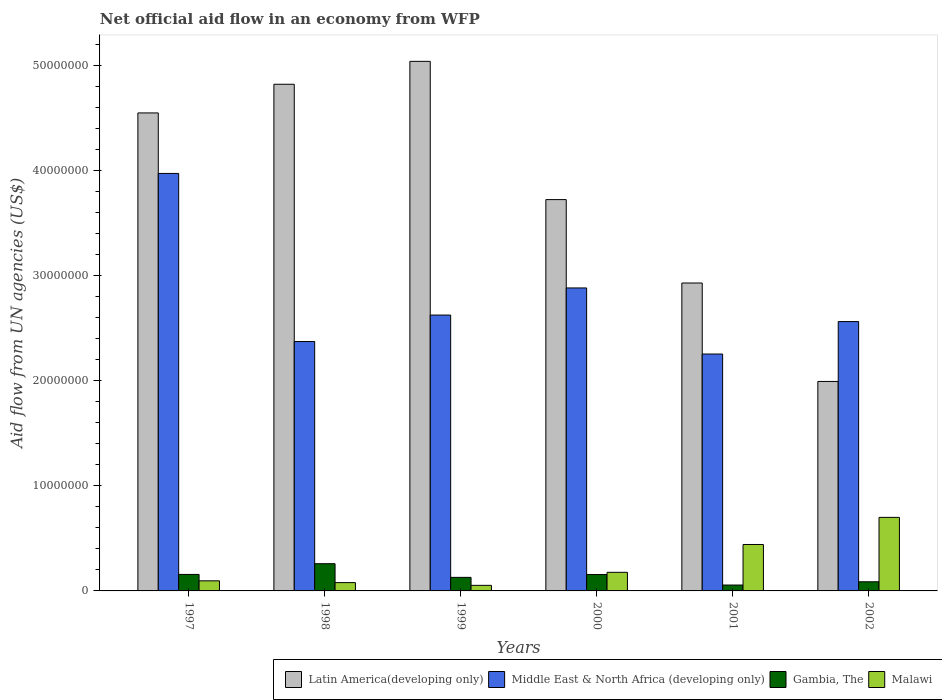How many different coloured bars are there?
Your response must be concise. 4. How many groups of bars are there?
Your response must be concise. 6. Are the number of bars per tick equal to the number of legend labels?
Your response must be concise. Yes. Are the number of bars on each tick of the X-axis equal?
Your response must be concise. Yes. How many bars are there on the 4th tick from the left?
Provide a succinct answer. 4. How many bars are there on the 3rd tick from the right?
Make the answer very short. 4. What is the label of the 1st group of bars from the left?
Provide a short and direct response. 1997. In how many cases, is the number of bars for a given year not equal to the number of legend labels?
Your answer should be very brief. 0. What is the net official aid flow in Latin America(developing only) in 1998?
Keep it short and to the point. 4.82e+07. Across all years, what is the maximum net official aid flow in Latin America(developing only)?
Provide a short and direct response. 5.04e+07. Across all years, what is the minimum net official aid flow in Middle East & North Africa (developing only)?
Offer a terse response. 2.26e+07. In which year was the net official aid flow in Middle East & North Africa (developing only) minimum?
Make the answer very short. 2001. What is the total net official aid flow in Middle East & North Africa (developing only) in the graph?
Keep it short and to the point. 1.67e+08. What is the difference between the net official aid flow in Middle East & North Africa (developing only) in 1998 and that in 2002?
Offer a very short reply. -1.90e+06. What is the difference between the net official aid flow in Latin America(developing only) in 1997 and the net official aid flow in Middle East & North Africa (developing only) in 2001?
Keep it short and to the point. 2.30e+07. What is the average net official aid flow in Latin America(developing only) per year?
Provide a short and direct response. 3.84e+07. In the year 1998, what is the difference between the net official aid flow in Middle East & North Africa (developing only) and net official aid flow in Malawi?
Provide a short and direct response. 2.30e+07. What is the ratio of the net official aid flow in Latin America(developing only) in 1999 to that in 2002?
Your response must be concise. 2.53. Is the net official aid flow in Middle East & North Africa (developing only) in 1997 less than that in 1999?
Your response must be concise. No. Is the difference between the net official aid flow in Middle East & North Africa (developing only) in 1999 and 2000 greater than the difference between the net official aid flow in Malawi in 1999 and 2000?
Make the answer very short. No. What is the difference between the highest and the second highest net official aid flow in Latin America(developing only)?
Keep it short and to the point. 2.18e+06. What is the difference between the highest and the lowest net official aid flow in Latin America(developing only)?
Your answer should be very brief. 3.05e+07. Is it the case that in every year, the sum of the net official aid flow in Gambia, The and net official aid flow in Malawi is greater than the sum of net official aid flow in Middle East & North Africa (developing only) and net official aid flow in Latin America(developing only)?
Keep it short and to the point. No. What does the 1st bar from the left in 2000 represents?
Provide a succinct answer. Latin America(developing only). What does the 4th bar from the right in 1998 represents?
Provide a short and direct response. Latin America(developing only). Is it the case that in every year, the sum of the net official aid flow in Malawi and net official aid flow in Latin America(developing only) is greater than the net official aid flow in Gambia, The?
Offer a terse response. Yes. Are all the bars in the graph horizontal?
Provide a short and direct response. No. How many years are there in the graph?
Your answer should be very brief. 6. What is the difference between two consecutive major ticks on the Y-axis?
Your response must be concise. 1.00e+07. Are the values on the major ticks of Y-axis written in scientific E-notation?
Your response must be concise. No. Does the graph contain any zero values?
Provide a succinct answer. No. Does the graph contain grids?
Ensure brevity in your answer.  No. How many legend labels are there?
Your response must be concise. 4. What is the title of the graph?
Your answer should be compact. Net official aid flow in an economy from WFP. What is the label or title of the Y-axis?
Your answer should be compact. Aid flow from UN agencies (US$). What is the Aid flow from UN agencies (US$) of Latin America(developing only) in 1997?
Offer a terse response. 4.55e+07. What is the Aid flow from UN agencies (US$) in Middle East & North Africa (developing only) in 1997?
Your answer should be very brief. 3.97e+07. What is the Aid flow from UN agencies (US$) of Gambia, The in 1997?
Keep it short and to the point. 1.57e+06. What is the Aid flow from UN agencies (US$) in Malawi in 1997?
Ensure brevity in your answer.  9.60e+05. What is the Aid flow from UN agencies (US$) of Latin America(developing only) in 1998?
Ensure brevity in your answer.  4.82e+07. What is the Aid flow from UN agencies (US$) of Middle East & North Africa (developing only) in 1998?
Give a very brief answer. 2.37e+07. What is the Aid flow from UN agencies (US$) in Gambia, The in 1998?
Your response must be concise. 2.59e+06. What is the Aid flow from UN agencies (US$) of Malawi in 1998?
Your answer should be compact. 7.90e+05. What is the Aid flow from UN agencies (US$) in Latin America(developing only) in 1999?
Offer a terse response. 5.04e+07. What is the Aid flow from UN agencies (US$) of Middle East & North Africa (developing only) in 1999?
Your answer should be very brief. 2.63e+07. What is the Aid flow from UN agencies (US$) of Gambia, The in 1999?
Your answer should be compact. 1.29e+06. What is the Aid flow from UN agencies (US$) in Malawi in 1999?
Provide a short and direct response. 5.30e+05. What is the Aid flow from UN agencies (US$) of Latin America(developing only) in 2000?
Keep it short and to the point. 3.72e+07. What is the Aid flow from UN agencies (US$) in Middle East & North Africa (developing only) in 2000?
Give a very brief answer. 2.88e+07. What is the Aid flow from UN agencies (US$) in Gambia, The in 2000?
Offer a terse response. 1.56e+06. What is the Aid flow from UN agencies (US$) of Malawi in 2000?
Make the answer very short. 1.77e+06. What is the Aid flow from UN agencies (US$) in Latin America(developing only) in 2001?
Offer a very short reply. 2.93e+07. What is the Aid flow from UN agencies (US$) of Middle East & North Africa (developing only) in 2001?
Keep it short and to the point. 2.26e+07. What is the Aid flow from UN agencies (US$) of Gambia, The in 2001?
Your response must be concise. 5.60e+05. What is the Aid flow from UN agencies (US$) in Malawi in 2001?
Provide a short and direct response. 4.42e+06. What is the Aid flow from UN agencies (US$) in Latin America(developing only) in 2002?
Offer a very short reply. 1.99e+07. What is the Aid flow from UN agencies (US$) of Middle East & North Africa (developing only) in 2002?
Ensure brevity in your answer.  2.56e+07. What is the Aid flow from UN agencies (US$) of Gambia, The in 2002?
Provide a succinct answer. 8.70e+05. Across all years, what is the maximum Aid flow from UN agencies (US$) of Latin America(developing only)?
Make the answer very short. 5.04e+07. Across all years, what is the maximum Aid flow from UN agencies (US$) in Middle East & North Africa (developing only)?
Make the answer very short. 3.97e+07. Across all years, what is the maximum Aid flow from UN agencies (US$) of Gambia, The?
Make the answer very short. 2.59e+06. Across all years, what is the minimum Aid flow from UN agencies (US$) in Latin America(developing only)?
Give a very brief answer. 1.99e+07. Across all years, what is the minimum Aid flow from UN agencies (US$) of Middle East & North Africa (developing only)?
Your answer should be compact. 2.26e+07. Across all years, what is the minimum Aid flow from UN agencies (US$) in Gambia, The?
Offer a very short reply. 5.60e+05. Across all years, what is the minimum Aid flow from UN agencies (US$) of Malawi?
Give a very brief answer. 5.30e+05. What is the total Aid flow from UN agencies (US$) of Latin America(developing only) in the graph?
Provide a succinct answer. 2.31e+08. What is the total Aid flow from UN agencies (US$) of Middle East & North Africa (developing only) in the graph?
Offer a very short reply. 1.67e+08. What is the total Aid flow from UN agencies (US$) in Gambia, The in the graph?
Provide a succinct answer. 8.44e+06. What is the total Aid flow from UN agencies (US$) of Malawi in the graph?
Provide a succinct answer. 1.55e+07. What is the difference between the Aid flow from UN agencies (US$) of Latin America(developing only) in 1997 and that in 1998?
Ensure brevity in your answer.  -2.73e+06. What is the difference between the Aid flow from UN agencies (US$) in Middle East & North Africa (developing only) in 1997 and that in 1998?
Offer a very short reply. 1.60e+07. What is the difference between the Aid flow from UN agencies (US$) in Gambia, The in 1997 and that in 1998?
Provide a short and direct response. -1.02e+06. What is the difference between the Aid flow from UN agencies (US$) in Latin America(developing only) in 1997 and that in 1999?
Offer a terse response. -4.91e+06. What is the difference between the Aid flow from UN agencies (US$) in Middle East & North Africa (developing only) in 1997 and that in 1999?
Your answer should be compact. 1.35e+07. What is the difference between the Aid flow from UN agencies (US$) of Gambia, The in 1997 and that in 1999?
Provide a succinct answer. 2.80e+05. What is the difference between the Aid flow from UN agencies (US$) of Malawi in 1997 and that in 1999?
Provide a short and direct response. 4.30e+05. What is the difference between the Aid flow from UN agencies (US$) in Latin America(developing only) in 1997 and that in 2000?
Provide a short and direct response. 8.25e+06. What is the difference between the Aid flow from UN agencies (US$) in Middle East & North Africa (developing only) in 1997 and that in 2000?
Make the answer very short. 1.09e+07. What is the difference between the Aid flow from UN agencies (US$) in Gambia, The in 1997 and that in 2000?
Provide a short and direct response. 10000. What is the difference between the Aid flow from UN agencies (US$) in Malawi in 1997 and that in 2000?
Ensure brevity in your answer.  -8.10e+05. What is the difference between the Aid flow from UN agencies (US$) of Latin America(developing only) in 1997 and that in 2001?
Make the answer very short. 1.62e+07. What is the difference between the Aid flow from UN agencies (US$) of Middle East & North Africa (developing only) in 1997 and that in 2001?
Your response must be concise. 1.72e+07. What is the difference between the Aid flow from UN agencies (US$) of Gambia, The in 1997 and that in 2001?
Make the answer very short. 1.01e+06. What is the difference between the Aid flow from UN agencies (US$) in Malawi in 1997 and that in 2001?
Your answer should be compact. -3.46e+06. What is the difference between the Aid flow from UN agencies (US$) in Latin America(developing only) in 1997 and that in 2002?
Ensure brevity in your answer.  2.56e+07. What is the difference between the Aid flow from UN agencies (US$) in Middle East & North Africa (developing only) in 1997 and that in 2002?
Give a very brief answer. 1.41e+07. What is the difference between the Aid flow from UN agencies (US$) in Gambia, The in 1997 and that in 2002?
Offer a very short reply. 7.00e+05. What is the difference between the Aid flow from UN agencies (US$) in Malawi in 1997 and that in 2002?
Provide a short and direct response. -6.04e+06. What is the difference between the Aid flow from UN agencies (US$) in Latin America(developing only) in 1998 and that in 1999?
Provide a short and direct response. -2.18e+06. What is the difference between the Aid flow from UN agencies (US$) in Middle East & North Africa (developing only) in 1998 and that in 1999?
Offer a terse response. -2.52e+06. What is the difference between the Aid flow from UN agencies (US$) of Gambia, The in 1998 and that in 1999?
Give a very brief answer. 1.30e+06. What is the difference between the Aid flow from UN agencies (US$) of Malawi in 1998 and that in 1999?
Offer a terse response. 2.60e+05. What is the difference between the Aid flow from UN agencies (US$) of Latin America(developing only) in 1998 and that in 2000?
Your answer should be compact. 1.10e+07. What is the difference between the Aid flow from UN agencies (US$) of Middle East & North Africa (developing only) in 1998 and that in 2000?
Your response must be concise. -5.10e+06. What is the difference between the Aid flow from UN agencies (US$) in Gambia, The in 1998 and that in 2000?
Ensure brevity in your answer.  1.03e+06. What is the difference between the Aid flow from UN agencies (US$) of Malawi in 1998 and that in 2000?
Make the answer very short. -9.80e+05. What is the difference between the Aid flow from UN agencies (US$) of Latin America(developing only) in 1998 and that in 2001?
Offer a terse response. 1.89e+07. What is the difference between the Aid flow from UN agencies (US$) in Middle East & North Africa (developing only) in 1998 and that in 2001?
Offer a very short reply. 1.19e+06. What is the difference between the Aid flow from UN agencies (US$) in Gambia, The in 1998 and that in 2001?
Offer a very short reply. 2.03e+06. What is the difference between the Aid flow from UN agencies (US$) of Malawi in 1998 and that in 2001?
Your response must be concise. -3.63e+06. What is the difference between the Aid flow from UN agencies (US$) of Latin America(developing only) in 1998 and that in 2002?
Ensure brevity in your answer.  2.83e+07. What is the difference between the Aid flow from UN agencies (US$) in Middle East & North Africa (developing only) in 1998 and that in 2002?
Provide a short and direct response. -1.90e+06. What is the difference between the Aid flow from UN agencies (US$) in Gambia, The in 1998 and that in 2002?
Your answer should be compact. 1.72e+06. What is the difference between the Aid flow from UN agencies (US$) of Malawi in 1998 and that in 2002?
Your response must be concise. -6.21e+06. What is the difference between the Aid flow from UN agencies (US$) of Latin America(developing only) in 1999 and that in 2000?
Offer a very short reply. 1.32e+07. What is the difference between the Aid flow from UN agencies (US$) of Middle East & North Africa (developing only) in 1999 and that in 2000?
Your answer should be compact. -2.58e+06. What is the difference between the Aid flow from UN agencies (US$) of Gambia, The in 1999 and that in 2000?
Keep it short and to the point. -2.70e+05. What is the difference between the Aid flow from UN agencies (US$) in Malawi in 1999 and that in 2000?
Offer a terse response. -1.24e+06. What is the difference between the Aid flow from UN agencies (US$) in Latin America(developing only) in 1999 and that in 2001?
Make the answer very short. 2.11e+07. What is the difference between the Aid flow from UN agencies (US$) of Middle East & North Africa (developing only) in 1999 and that in 2001?
Give a very brief answer. 3.71e+06. What is the difference between the Aid flow from UN agencies (US$) in Gambia, The in 1999 and that in 2001?
Give a very brief answer. 7.30e+05. What is the difference between the Aid flow from UN agencies (US$) of Malawi in 1999 and that in 2001?
Provide a succinct answer. -3.89e+06. What is the difference between the Aid flow from UN agencies (US$) of Latin America(developing only) in 1999 and that in 2002?
Keep it short and to the point. 3.05e+07. What is the difference between the Aid flow from UN agencies (US$) in Middle East & North Africa (developing only) in 1999 and that in 2002?
Give a very brief answer. 6.20e+05. What is the difference between the Aid flow from UN agencies (US$) of Gambia, The in 1999 and that in 2002?
Give a very brief answer. 4.20e+05. What is the difference between the Aid flow from UN agencies (US$) in Malawi in 1999 and that in 2002?
Your answer should be very brief. -6.47e+06. What is the difference between the Aid flow from UN agencies (US$) in Latin America(developing only) in 2000 and that in 2001?
Your answer should be compact. 7.94e+06. What is the difference between the Aid flow from UN agencies (US$) in Middle East & North Africa (developing only) in 2000 and that in 2001?
Offer a very short reply. 6.29e+06. What is the difference between the Aid flow from UN agencies (US$) of Gambia, The in 2000 and that in 2001?
Offer a very short reply. 1.00e+06. What is the difference between the Aid flow from UN agencies (US$) of Malawi in 2000 and that in 2001?
Offer a terse response. -2.65e+06. What is the difference between the Aid flow from UN agencies (US$) in Latin America(developing only) in 2000 and that in 2002?
Make the answer very short. 1.73e+07. What is the difference between the Aid flow from UN agencies (US$) in Middle East & North Africa (developing only) in 2000 and that in 2002?
Keep it short and to the point. 3.20e+06. What is the difference between the Aid flow from UN agencies (US$) of Gambia, The in 2000 and that in 2002?
Your answer should be very brief. 6.90e+05. What is the difference between the Aid flow from UN agencies (US$) of Malawi in 2000 and that in 2002?
Your response must be concise. -5.23e+06. What is the difference between the Aid flow from UN agencies (US$) in Latin America(developing only) in 2001 and that in 2002?
Offer a terse response. 9.37e+06. What is the difference between the Aid flow from UN agencies (US$) of Middle East & North Africa (developing only) in 2001 and that in 2002?
Make the answer very short. -3.09e+06. What is the difference between the Aid flow from UN agencies (US$) of Gambia, The in 2001 and that in 2002?
Make the answer very short. -3.10e+05. What is the difference between the Aid flow from UN agencies (US$) in Malawi in 2001 and that in 2002?
Make the answer very short. -2.58e+06. What is the difference between the Aid flow from UN agencies (US$) of Latin America(developing only) in 1997 and the Aid flow from UN agencies (US$) of Middle East & North Africa (developing only) in 1998?
Offer a terse response. 2.18e+07. What is the difference between the Aid flow from UN agencies (US$) of Latin America(developing only) in 1997 and the Aid flow from UN agencies (US$) of Gambia, The in 1998?
Your answer should be very brief. 4.29e+07. What is the difference between the Aid flow from UN agencies (US$) in Latin America(developing only) in 1997 and the Aid flow from UN agencies (US$) in Malawi in 1998?
Offer a terse response. 4.47e+07. What is the difference between the Aid flow from UN agencies (US$) of Middle East & North Africa (developing only) in 1997 and the Aid flow from UN agencies (US$) of Gambia, The in 1998?
Provide a short and direct response. 3.72e+07. What is the difference between the Aid flow from UN agencies (US$) in Middle East & North Africa (developing only) in 1997 and the Aid flow from UN agencies (US$) in Malawi in 1998?
Give a very brief answer. 3.90e+07. What is the difference between the Aid flow from UN agencies (US$) of Gambia, The in 1997 and the Aid flow from UN agencies (US$) of Malawi in 1998?
Ensure brevity in your answer.  7.80e+05. What is the difference between the Aid flow from UN agencies (US$) of Latin America(developing only) in 1997 and the Aid flow from UN agencies (US$) of Middle East & North Africa (developing only) in 1999?
Your response must be concise. 1.92e+07. What is the difference between the Aid flow from UN agencies (US$) of Latin America(developing only) in 1997 and the Aid flow from UN agencies (US$) of Gambia, The in 1999?
Provide a short and direct response. 4.42e+07. What is the difference between the Aid flow from UN agencies (US$) in Latin America(developing only) in 1997 and the Aid flow from UN agencies (US$) in Malawi in 1999?
Offer a very short reply. 4.50e+07. What is the difference between the Aid flow from UN agencies (US$) in Middle East & North Africa (developing only) in 1997 and the Aid flow from UN agencies (US$) in Gambia, The in 1999?
Make the answer very short. 3.84e+07. What is the difference between the Aid flow from UN agencies (US$) in Middle East & North Africa (developing only) in 1997 and the Aid flow from UN agencies (US$) in Malawi in 1999?
Your answer should be compact. 3.92e+07. What is the difference between the Aid flow from UN agencies (US$) in Gambia, The in 1997 and the Aid flow from UN agencies (US$) in Malawi in 1999?
Give a very brief answer. 1.04e+06. What is the difference between the Aid flow from UN agencies (US$) in Latin America(developing only) in 1997 and the Aid flow from UN agencies (US$) in Middle East & North Africa (developing only) in 2000?
Make the answer very short. 1.67e+07. What is the difference between the Aid flow from UN agencies (US$) of Latin America(developing only) in 1997 and the Aid flow from UN agencies (US$) of Gambia, The in 2000?
Make the answer very short. 4.39e+07. What is the difference between the Aid flow from UN agencies (US$) in Latin America(developing only) in 1997 and the Aid flow from UN agencies (US$) in Malawi in 2000?
Your response must be concise. 4.37e+07. What is the difference between the Aid flow from UN agencies (US$) in Middle East & North Africa (developing only) in 1997 and the Aid flow from UN agencies (US$) in Gambia, The in 2000?
Make the answer very short. 3.82e+07. What is the difference between the Aid flow from UN agencies (US$) of Middle East & North Africa (developing only) in 1997 and the Aid flow from UN agencies (US$) of Malawi in 2000?
Provide a succinct answer. 3.80e+07. What is the difference between the Aid flow from UN agencies (US$) of Gambia, The in 1997 and the Aid flow from UN agencies (US$) of Malawi in 2000?
Your response must be concise. -2.00e+05. What is the difference between the Aid flow from UN agencies (US$) in Latin America(developing only) in 1997 and the Aid flow from UN agencies (US$) in Middle East & North Africa (developing only) in 2001?
Ensure brevity in your answer.  2.30e+07. What is the difference between the Aid flow from UN agencies (US$) in Latin America(developing only) in 1997 and the Aid flow from UN agencies (US$) in Gambia, The in 2001?
Offer a terse response. 4.49e+07. What is the difference between the Aid flow from UN agencies (US$) of Latin America(developing only) in 1997 and the Aid flow from UN agencies (US$) of Malawi in 2001?
Provide a succinct answer. 4.11e+07. What is the difference between the Aid flow from UN agencies (US$) in Middle East & North Africa (developing only) in 1997 and the Aid flow from UN agencies (US$) in Gambia, The in 2001?
Your answer should be very brief. 3.92e+07. What is the difference between the Aid flow from UN agencies (US$) of Middle East & North Africa (developing only) in 1997 and the Aid flow from UN agencies (US$) of Malawi in 2001?
Ensure brevity in your answer.  3.53e+07. What is the difference between the Aid flow from UN agencies (US$) in Gambia, The in 1997 and the Aid flow from UN agencies (US$) in Malawi in 2001?
Give a very brief answer. -2.85e+06. What is the difference between the Aid flow from UN agencies (US$) of Latin America(developing only) in 1997 and the Aid flow from UN agencies (US$) of Middle East & North Africa (developing only) in 2002?
Offer a terse response. 1.99e+07. What is the difference between the Aid flow from UN agencies (US$) of Latin America(developing only) in 1997 and the Aid flow from UN agencies (US$) of Gambia, The in 2002?
Ensure brevity in your answer.  4.46e+07. What is the difference between the Aid flow from UN agencies (US$) in Latin America(developing only) in 1997 and the Aid flow from UN agencies (US$) in Malawi in 2002?
Offer a terse response. 3.85e+07. What is the difference between the Aid flow from UN agencies (US$) in Middle East & North Africa (developing only) in 1997 and the Aid flow from UN agencies (US$) in Gambia, The in 2002?
Offer a very short reply. 3.89e+07. What is the difference between the Aid flow from UN agencies (US$) in Middle East & North Africa (developing only) in 1997 and the Aid flow from UN agencies (US$) in Malawi in 2002?
Your answer should be compact. 3.27e+07. What is the difference between the Aid flow from UN agencies (US$) in Gambia, The in 1997 and the Aid flow from UN agencies (US$) in Malawi in 2002?
Ensure brevity in your answer.  -5.43e+06. What is the difference between the Aid flow from UN agencies (US$) of Latin America(developing only) in 1998 and the Aid flow from UN agencies (US$) of Middle East & North Africa (developing only) in 1999?
Provide a short and direct response. 2.20e+07. What is the difference between the Aid flow from UN agencies (US$) in Latin America(developing only) in 1998 and the Aid flow from UN agencies (US$) in Gambia, The in 1999?
Keep it short and to the point. 4.69e+07. What is the difference between the Aid flow from UN agencies (US$) in Latin America(developing only) in 1998 and the Aid flow from UN agencies (US$) in Malawi in 1999?
Provide a short and direct response. 4.77e+07. What is the difference between the Aid flow from UN agencies (US$) of Middle East & North Africa (developing only) in 1998 and the Aid flow from UN agencies (US$) of Gambia, The in 1999?
Your response must be concise. 2.24e+07. What is the difference between the Aid flow from UN agencies (US$) in Middle East & North Africa (developing only) in 1998 and the Aid flow from UN agencies (US$) in Malawi in 1999?
Keep it short and to the point. 2.32e+07. What is the difference between the Aid flow from UN agencies (US$) of Gambia, The in 1998 and the Aid flow from UN agencies (US$) of Malawi in 1999?
Offer a terse response. 2.06e+06. What is the difference between the Aid flow from UN agencies (US$) in Latin America(developing only) in 1998 and the Aid flow from UN agencies (US$) in Middle East & North Africa (developing only) in 2000?
Provide a succinct answer. 1.94e+07. What is the difference between the Aid flow from UN agencies (US$) in Latin America(developing only) in 1998 and the Aid flow from UN agencies (US$) in Gambia, The in 2000?
Provide a short and direct response. 4.67e+07. What is the difference between the Aid flow from UN agencies (US$) of Latin America(developing only) in 1998 and the Aid flow from UN agencies (US$) of Malawi in 2000?
Your answer should be very brief. 4.65e+07. What is the difference between the Aid flow from UN agencies (US$) in Middle East & North Africa (developing only) in 1998 and the Aid flow from UN agencies (US$) in Gambia, The in 2000?
Provide a succinct answer. 2.22e+07. What is the difference between the Aid flow from UN agencies (US$) in Middle East & North Africa (developing only) in 1998 and the Aid flow from UN agencies (US$) in Malawi in 2000?
Make the answer very short. 2.20e+07. What is the difference between the Aid flow from UN agencies (US$) in Gambia, The in 1998 and the Aid flow from UN agencies (US$) in Malawi in 2000?
Provide a succinct answer. 8.20e+05. What is the difference between the Aid flow from UN agencies (US$) of Latin America(developing only) in 1998 and the Aid flow from UN agencies (US$) of Middle East & North Africa (developing only) in 2001?
Ensure brevity in your answer.  2.57e+07. What is the difference between the Aid flow from UN agencies (US$) of Latin America(developing only) in 1998 and the Aid flow from UN agencies (US$) of Gambia, The in 2001?
Make the answer very short. 4.77e+07. What is the difference between the Aid flow from UN agencies (US$) of Latin America(developing only) in 1998 and the Aid flow from UN agencies (US$) of Malawi in 2001?
Your answer should be compact. 4.38e+07. What is the difference between the Aid flow from UN agencies (US$) in Middle East & North Africa (developing only) in 1998 and the Aid flow from UN agencies (US$) in Gambia, The in 2001?
Your response must be concise. 2.32e+07. What is the difference between the Aid flow from UN agencies (US$) of Middle East & North Africa (developing only) in 1998 and the Aid flow from UN agencies (US$) of Malawi in 2001?
Make the answer very short. 1.93e+07. What is the difference between the Aid flow from UN agencies (US$) in Gambia, The in 1998 and the Aid flow from UN agencies (US$) in Malawi in 2001?
Keep it short and to the point. -1.83e+06. What is the difference between the Aid flow from UN agencies (US$) in Latin America(developing only) in 1998 and the Aid flow from UN agencies (US$) in Middle East & North Africa (developing only) in 2002?
Your answer should be very brief. 2.26e+07. What is the difference between the Aid flow from UN agencies (US$) in Latin America(developing only) in 1998 and the Aid flow from UN agencies (US$) in Gambia, The in 2002?
Provide a succinct answer. 4.74e+07. What is the difference between the Aid flow from UN agencies (US$) of Latin America(developing only) in 1998 and the Aid flow from UN agencies (US$) of Malawi in 2002?
Your response must be concise. 4.12e+07. What is the difference between the Aid flow from UN agencies (US$) of Middle East & North Africa (developing only) in 1998 and the Aid flow from UN agencies (US$) of Gambia, The in 2002?
Your answer should be very brief. 2.29e+07. What is the difference between the Aid flow from UN agencies (US$) of Middle East & North Africa (developing only) in 1998 and the Aid flow from UN agencies (US$) of Malawi in 2002?
Your answer should be compact. 1.67e+07. What is the difference between the Aid flow from UN agencies (US$) in Gambia, The in 1998 and the Aid flow from UN agencies (US$) in Malawi in 2002?
Your answer should be compact. -4.41e+06. What is the difference between the Aid flow from UN agencies (US$) of Latin America(developing only) in 1999 and the Aid flow from UN agencies (US$) of Middle East & North Africa (developing only) in 2000?
Your answer should be compact. 2.16e+07. What is the difference between the Aid flow from UN agencies (US$) in Latin America(developing only) in 1999 and the Aid flow from UN agencies (US$) in Gambia, The in 2000?
Make the answer very short. 4.88e+07. What is the difference between the Aid flow from UN agencies (US$) in Latin America(developing only) in 1999 and the Aid flow from UN agencies (US$) in Malawi in 2000?
Your answer should be very brief. 4.86e+07. What is the difference between the Aid flow from UN agencies (US$) in Middle East & North Africa (developing only) in 1999 and the Aid flow from UN agencies (US$) in Gambia, The in 2000?
Your response must be concise. 2.47e+07. What is the difference between the Aid flow from UN agencies (US$) in Middle East & North Africa (developing only) in 1999 and the Aid flow from UN agencies (US$) in Malawi in 2000?
Offer a very short reply. 2.45e+07. What is the difference between the Aid flow from UN agencies (US$) of Gambia, The in 1999 and the Aid flow from UN agencies (US$) of Malawi in 2000?
Provide a succinct answer. -4.80e+05. What is the difference between the Aid flow from UN agencies (US$) in Latin America(developing only) in 1999 and the Aid flow from UN agencies (US$) in Middle East & North Africa (developing only) in 2001?
Your answer should be very brief. 2.79e+07. What is the difference between the Aid flow from UN agencies (US$) of Latin America(developing only) in 1999 and the Aid flow from UN agencies (US$) of Gambia, The in 2001?
Provide a succinct answer. 4.98e+07. What is the difference between the Aid flow from UN agencies (US$) in Latin America(developing only) in 1999 and the Aid flow from UN agencies (US$) in Malawi in 2001?
Your answer should be compact. 4.60e+07. What is the difference between the Aid flow from UN agencies (US$) in Middle East & North Africa (developing only) in 1999 and the Aid flow from UN agencies (US$) in Gambia, The in 2001?
Ensure brevity in your answer.  2.57e+07. What is the difference between the Aid flow from UN agencies (US$) of Middle East & North Africa (developing only) in 1999 and the Aid flow from UN agencies (US$) of Malawi in 2001?
Provide a short and direct response. 2.18e+07. What is the difference between the Aid flow from UN agencies (US$) of Gambia, The in 1999 and the Aid flow from UN agencies (US$) of Malawi in 2001?
Provide a succinct answer. -3.13e+06. What is the difference between the Aid flow from UN agencies (US$) of Latin America(developing only) in 1999 and the Aid flow from UN agencies (US$) of Middle East & North Africa (developing only) in 2002?
Your response must be concise. 2.48e+07. What is the difference between the Aid flow from UN agencies (US$) of Latin America(developing only) in 1999 and the Aid flow from UN agencies (US$) of Gambia, The in 2002?
Your answer should be compact. 4.95e+07. What is the difference between the Aid flow from UN agencies (US$) in Latin America(developing only) in 1999 and the Aid flow from UN agencies (US$) in Malawi in 2002?
Make the answer very short. 4.34e+07. What is the difference between the Aid flow from UN agencies (US$) in Middle East & North Africa (developing only) in 1999 and the Aid flow from UN agencies (US$) in Gambia, The in 2002?
Ensure brevity in your answer.  2.54e+07. What is the difference between the Aid flow from UN agencies (US$) of Middle East & North Africa (developing only) in 1999 and the Aid flow from UN agencies (US$) of Malawi in 2002?
Offer a very short reply. 1.93e+07. What is the difference between the Aid flow from UN agencies (US$) in Gambia, The in 1999 and the Aid flow from UN agencies (US$) in Malawi in 2002?
Provide a succinct answer. -5.71e+06. What is the difference between the Aid flow from UN agencies (US$) of Latin America(developing only) in 2000 and the Aid flow from UN agencies (US$) of Middle East & North Africa (developing only) in 2001?
Your answer should be very brief. 1.47e+07. What is the difference between the Aid flow from UN agencies (US$) of Latin America(developing only) in 2000 and the Aid flow from UN agencies (US$) of Gambia, The in 2001?
Give a very brief answer. 3.67e+07. What is the difference between the Aid flow from UN agencies (US$) of Latin America(developing only) in 2000 and the Aid flow from UN agencies (US$) of Malawi in 2001?
Ensure brevity in your answer.  3.28e+07. What is the difference between the Aid flow from UN agencies (US$) of Middle East & North Africa (developing only) in 2000 and the Aid flow from UN agencies (US$) of Gambia, The in 2001?
Keep it short and to the point. 2.83e+07. What is the difference between the Aid flow from UN agencies (US$) in Middle East & North Africa (developing only) in 2000 and the Aid flow from UN agencies (US$) in Malawi in 2001?
Ensure brevity in your answer.  2.44e+07. What is the difference between the Aid flow from UN agencies (US$) in Gambia, The in 2000 and the Aid flow from UN agencies (US$) in Malawi in 2001?
Your response must be concise. -2.86e+06. What is the difference between the Aid flow from UN agencies (US$) in Latin America(developing only) in 2000 and the Aid flow from UN agencies (US$) in Middle East & North Africa (developing only) in 2002?
Ensure brevity in your answer.  1.16e+07. What is the difference between the Aid flow from UN agencies (US$) of Latin America(developing only) in 2000 and the Aid flow from UN agencies (US$) of Gambia, The in 2002?
Keep it short and to the point. 3.64e+07. What is the difference between the Aid flow from UN agencies (US$) in Latin America(developing only) in 2000 and the Aid flow from UN agencies (US$) in Malawi in 2002?
Ensure brevity in your answer.  3.02e+07. What is the difference between the Aid flow from UN agencies (US$) in Middle East & North Africa (developing only) in 2000 and the Aid flow from UN agencies (US$) in Gambia, The in 2002?
Give a very brief answer. 2.80e+07. What is the difference between the Aid flow from UN agencies (US$) in Middle East & North Africa (developing only) in 2000 and the Aid flow from UN agencies (US$) in Malawi in 2002?
Your answer should be very brief. 2.18e+07. What is the difference between the Aid flow from UN agencies (US$) in Gambia, The in 2000 and the Aid flow from UN agencies (US$) in Malawi in 2002?
Offer a very short reply. -5.44e+06. What is the difference between the Aid flow from UN agencies (US$) of Latin America(developing only) in 2001 and the Aid flow from UN agencies (US$) of Middle East & North Africa (developing only) in 2002?
Make the answer very short. 3.67e+06. What is the difference between the Aid flow from UN agencies (US$) in Latin America(developing only) in 2001 and the Aid flow from UN agencies (US$) in Gambia, The in 2002?
Keep it short and to the point. 2.84e+07. What is the difference between the Aid flow from UN agencies (US$) in Latin America(developing only) in 2001 and the Aid flow from UN agencies (US$) in Malawi in 2002?
Offer a very short reply. 2.23e+07. What is the difference between the Aid flow from UN agencies (US$) in Middle East & North Africa (developing only) in 2001 and the Aid flow from UN agencies (US$) in Gambia, The in 2002?
Offer a terse response. 2.17e+07. What is the difference between the Aid flow from UN agencies (US$) of Middle East & North Africa (developing only) in 2001 and the Aid flow from UN agencies (US$) of Malawi in 2002?
Provide a succinct answer. 1.56e+07. What is the difference between the Aid flow from UN agencies (US$) in Gambia, The in 2001 and the Aid flow from UN agencies (US$) in Malawi in 2002?
Make the answer very short. -6.44e+06. What is the average Aid flow from UN agencies (US$) in Latin America(developing only) per year?
Ensure brevity in your answer.  3.84e+07. What is the average Aid flow from UN agencies (US$) of Middle East & North Africa (developing only) per year?
Your answer should be compact. 2.78e+07. What is the average Aid flow from UN agencies (US$) in Gambia, The per year?
Provide a succinct answer. 1.41e+06. What is the average Aid flow from UN agencies (US$) in Malawi per year?
Offer a terse response. 2.58e+06. In the year 1997, what is the difference between the Aid flow from UN agencies (US$) of Latin America(developing only) and Aid flow from UN agencies (US$) of Middle East & North Africa (developing only)?
Offer a terse response. 5.76e+06. In the year 1997, what is the difference between the Aid flow from UN agencies (US$) in Latin America(developing only) and Aid flow from UN agencies (US$) in Gambia, The?
Provide a short and direct response. 4.39e+07. In the year 1997, what is the difference between the Aid flow from UN agencies (US$) of Latin America(developing only) and Aid flow from UN agencies (US$) of Malawi?
Ensure brevity in your answer.  4.45e+07. In the year 1997, what is the difference between the Aid flow from UN agencies (US$) of Middle East & North Africa (developing only) and Aid flow from UN agencies (US$) of Gambia, The?
Your answer should be compact. 3.82e+07. In the year 1997, what is the difference between the Aid flow from UN agencies (US$) of Middle East & North Africa (developing only) and Aid flow from UN agencies (US$) of Malawi?
Provide a succinct answer. 3.88e+07. In the year 1997, what is the difference between the Aid flow from UN agencies (US$) of Gambia, The and Aid flow from UN agencies (US$) of Malawi?
Offer a very short reply. 6.10e+05. In the year 1998, what is the difference between the Aid flow from UN agencies (US$) of Latin America(developing only) and Aid flow from UN agencies (US$) of Middle East & North Africa (developing only)?
Your answer should be very brief. 2.45e+07. In the year 1998, what is the difference between the Aid flow from UN agencies (US$) of Latin America(developing only) and Aid flow from UN agencies (US$) of Gambia, The?
Your answer should be compact. 4.56e+07. In the year 1998, what is the difference between the Aid flow from UN agencies (US$) in Latin America(developing only) and Aid flow from UN agencies (US$) in Malawi?
Offer a terse response. 4.74e+07. In the year 1998, what is the difference between the Aid flow from UN agencies (US$) of Middle East & North Africa (developing only) and Aid flow from UN agencies (US$) of Gambia, The?
Give a very brief answer. 2.12e+07. In the year 1998, what is the difference between the Aid flow from UN agencies (US$) in Middle East & North Africa (developing only) and Aid flow from UN agencies (US$) in Malawi?
Provide a short and direct response. 2.30e+07. In the year 1998, what is the difference between the Aid flow from UN agencies (US$) of Gambia, The and Aid flow from UN agencies (US$) of Malawi?
Ensure brevity in your answer.  1.80e+06. In the year 1999, what is the difference between the Aid flow from UN agencies (US$) in Latin America(developing only) and Aid flow from UN agencies (US$) in Middle East & North Africa (developing only)?
Your answer should be very brief. 2.42e+07. In the year 1999, what is the difference between the Aid flow from UN agencies (US$) in Latin America(developing only) and Aid flow from UN agencies (US$) in Gambia, The?
Your response must be concise. 4.91e+07. In the year 1999, what is the difference between the Aid flow from UN agencies (US$) of Latin America(developing only) and Aid flow from UN agencies (US$) of Malawi?
Ensure brevity in your answer.  4.99e+07. In the year 1999, what is the difference between the Aid flow from UN agencies (US$) in Middle East & North Africa (developing only) and Aid flow from UN agencies (US$) in Gambia, The?
Your answer should be very brief. 2.50e+07. In the year 1999, what is the difference between the Aid flow from UN agencies (US$) in Middle East & North Africa (developing only) and Aid flow from UN agencies (US$) in Malawi?
Your answer should be compact. 2.57e+07. In the year 1999, what is the difference between the Aid flow from UN agencies (US$) in Gambia, The and Aid flow from UN agencies (US$) in Malawi?
Provide a succinct answer. 7.60e+05. In the year 2000, what is the difference between the Aid flow from UN agencies (US$) in Latin America(developing only) and Aid flow from UN agencies (US$) in Middle East & North Africa (developing only)?
Your answer should be compact. 8.41e+06. In the year 2000, what is the difference between the Aid flow from UN agencies (US$) of Latin America(developing only) and Aid flow from UN agencies (US$) of Gambia, The?
Your answer should be compact. 3.57e+07. In the year 2000, what is the difference between the Aid flow from UN agencies (US$) of Latin America(developing only) and Aid flow from UN agencies (US$) of Malawi?
Provide a succinct answer. 3.55e+07. In the year 2000, what is the difference between the Aid flow from UN agencies (US$) in Middle East & North Africa (developing only) and Aid flow from UN agencies (US$) in Gambia, The?
Provide a short and direct response. 2.73e+07. In the year 2000, what is the difference between the Aid flow from UN agencies (US$) of Middle East & North Africa (developing only) and Aid flow from UN agencies (US$) of Malawi?
Give a very brief answer. 2.71e+07. In the year 2001, what is the difference between the Aid flow from UN agencies (US$) in Latin America(developing only) and Aid flow from UN agencies (US$) in Middle East & North Africa (developing only)?
Offer a very short reply. 6.76e+06. In the year 2001, what is the difference between the Aid flow from UN agencies (US$) in Latin America(developing only) and Aid flow from UN agencies (US$) in Gambia, The?
Your answer should be very brief. 2.88e+07. In the year 2001, what is the difference between the Aid flow from UN agencies (US$) of Latin America(developing only) and Aid flow from UN agencies (US$) of Malawi?
Make the answer very short. 2.49e+07. In the year 2001, what is the difference between the Aid flow from UN agencies (US$) in Middle East & North Africa (developing only) and Aid flow from UN agencies (US$) in Gambia, The?
Give a very brief answer. 2.20e+07. In the year 2001, what is the difference between the Aid flow from UN agencies (US$) of Middle East & North Africa (developing only) and Aid flow from UN agencies (US$) of Malawi?
Make the answer very short. 1.81e+07. In the year 2001, what is the difference between the Aid flow from UN agencies (US$) in Gambia, The and Aid flow from UN agencies (US$) in Malawi?
Your answer should be compact. -3.86e+06. In the year 2002, what is the difference between the Aid flow from UN agencies (US$) in Latin America(developing only) and Aid flow from UN agencies (US$) in Middle East & North Africa (developing only)?
Give a very brief answer. -5.70e+06. In the year 2002, what is the difference between the Aid flow from UN agencies (US$) of Latin America(developing only) and Aid flow from UN agencies (US$) of Gambia, The?
Provide a succinct answer. 1.91e+07. In the year 2002, what is the difference between the Aid flow from UN agencies (US$) in Latin America(developing only) and Aid flow from UN agencies (US$) in Malawi?
Offer a very short reply. 1.29e+07. In the year 2002, what is the difference between the Aid flow from UN agencies (US$) of Middle East & North Africa (developing only) and Aid flow from UN agencies (US$) of Gambia, The?
Your answer should be very brief. 2.48e+07. In the year 2002, what is the difference between the Aid flow from UN agencies (US$) in Middle East & North Africa (developing only) and Aid flow from UN agencies (US$) in Malawi?
Make the answer very short. 1.86e+07. In the year 2002, what is the difference between the Aid flow from UN agencies (US$) in Gambia, The and Aid flow from UN agencies (US$) in Malawi?
Offer a terse response. -6.13e+06. What is the ratio of the Aid flow from UN agencies (US$) in Latin America(developing only) in 1997 to that in 1998?
Your response must be concise. 0.94. What is the ratio of the Aid flow from UN agencies (US$) in Middle East & North Africa (developing only) in 1997 to that in 1998?
Keep it short and to the point. 1.67. What is the ratio of the Aid flow from UN agencies (US$) in Gambia, The in 1997 to that in 1998?
Offer a very short reply. 0.61. What is the ratio of the Aid flow from UN agencies (US$) in Malawi in 1997 to that in 1998?
Offer a very short reply. 1.22. What is the ratio of the Aid flow from UN agencies (US$) in Latin America(developing only) in 1997 to that in 1999?
Ensure brevity in your answer.  0.9. What is the ratio of the Aid flow from UN agencies (US$) of Middle East & North Africa (developing only) in 1997 to that in 1999?
Your answer should be very brief. 1.51. What is the ratio of the Aid flow from UN agencies (US$) of Gambia, The in 1997 to that in 1999?
Provide a succinct answer. 1.22. What is the ratio of the Aid flow from UN agencies (US$) of Malawi in 1997 to that in 1999?
Ensure brevity in your answer.  1.81. What is the ratio of the Aid flow from UN agencies (US$) in Latin America(developing only) in 1997 to that in 2000?
Make the answer very short. 1.22. What is the ratio of the Aid flow from UN agencies (US$) in Middle East & North Africa (developing only) in 1997 to that in 2000?
Provide a succinct answer. 1.38. What is the ratio of the Aid flow from UN agencies (US$) in Gambia, The in 1997 to that in 2000?
Your answer should be very brief. 1.01. What is the ratio of the Aid flow from UN agencies (US$) in Malawi in 1997 to that in 2000?
Give a very brief answer. 0.54. What is the ratio of the Aid flow from UN agencies (US$) in Latin America(developing only) in 1997 to that in 2001?
Make the answer very short. 1.55. What is the ratio of the Aid flow from UN agencies (US$) of Middle East & North Africa (developing only) in 1997 to that in 2001?
Ensure brevity in your answer.  1.76. What is the ratio of the Aid flow from UN agencies (US$) of Gambia, The in 1997 to that in 2001?
Your answer should be compact. 2.8. What is the ratio of the Aid flow from UN agencies (US$) in Malawi in 1997 to that in 2001?
Offer a terse response. 0.22. What is the ratio of the Aid flow from UN agencies (US$) in Latin America(developing only) in 1997 to that in 2002?
Offer a terse response. 2.28. What is the ratio of the Aid flow from UN agencies (US$) in Middle East & North Africa (developing only) in 1997 to that in 2002?
Your answer should be very brief. 1.55. What is the ratio of the Aid flow from UN agencies (US$) of Gambia, The in 1997 to that in 2002?
Make the answer very short. 1.8. What is the ratio of the Aid flow from UN agencies (US$) of Malawi in 1997 to that in 2002?
Your answer should be compact. 0.14. What is the ratio of the Aid flow from UN agencies (US$) of Latin America(developing only) in 1998 to that in 1999?
Make the answer very short. 0.96. What is the ratio of the Aid flow from UN agencies (US$) in Middle East & North Africa (developing only) in 1998 to that in 1999?
Keep it short and to the point. 0.9. What is the ratio of the Aid flow from UN agencies (US$) of Gambia, The in 1998 to that in 1999?
Your answer should be compact. 2.01. What is the ratio of the Aid flow from UN agencies (US$) in Malawi in 1998 to that in 1999?
Keep it short and to the point. 1.49. What is the ratio of the Aid flow from UN agencies (US$) in Latin America(developing only) in 1998 to that in 2000?
Offer a very short reply. 1.29. What is the ratio of the Aid flow from UN agencies (US$) of Middle East & North Africa (developing only) in 1998 to that in 2000?
Provide a succinct answer. 0.82. What is the ratio of the Aid flow from UN agencies (US$) of Gambia, The in 1998 to that in 2000?
Offer a very short reply. 1.66. What is the ratio of the Aid flow from UN agencies (US$) in Malawi in 1998 to that in 2000?
Your answer should be very brief. 0.45. What is the ratio of the Aid flow from UN agencies (US$) in Latin America(developing only) in 1998 to that in 2001?
Ensure brevity in your answer.  1.65. What is the ratio of the Aid flow from UN agencies (US$) in Middle East & North Africa (developing only) in 1998 to that in 2001?
Keep it short and to the point. 1.05. What is the ratio of the Aid flow from UN agencies (US$) in Gambia, The in 1998 to that in 2001?
Your response must be concise. 4.62. What is the ratio of the Aid flow from UN agencies (US$) of Malawi in 1998 to that in 2001?
Provide a short and direct response. 0.18. What is the ratio of the Aid flow from UN agencies (US$) of Latin America(developing only) in 1998 to that in 2002?
Ensure brevity in your answer.  2.42. What is the ratio of the Aid flow from UN agencies (US$) of Middle East & North Africa (developing only) in 1998 to that in 2002?
Make the answer very short. 0.93. What is the ratio of the Aid flow from UN agencies (US$) in Gambia, The in 1998 to that in 2002?
Make the answer very short. 2.98. What is the ratio of the Aid flow from UN agencies (US$) in Malawi in 1998 to that in 2002?
Your answer should be compact. 0.11. What is the ratio of the Aid flow from UN agencies (US$) in Latin America(developing only) in 1999 to that in 2000?
Make the answer very short. 1.35. What is the ratio of the Aid flow from UN agencies (US$) of Middle East & North Africa (developing only) in 1999 to that in 2000?
Your response must be concise. 0.91. What is the ratio of the Aid flow from UN agencies (US$) in Gambia, The in 1999 to that in 2000?
Keep it short and to the point. 0.83. What is the ratio of the Aid flow from UN agencies (US$) in Malawi in 1999 to that in 2000?
Provide a succinct answer. 0.3. What is the ratio of the Aid flow from UN agencies (US$) in Latin America(developing only) in 1999 to that in 2001?
Offer a terse response. 1.72. What is the ratio of the Aid flow from UN agencies (US$) of Middle East & North Africa (developing only) in 1999 to that in 2001?
Make the answer very short. 1.16. What is the ratio of the Aid flow from UN agencies (US$) of Gambia, The in 1999 to that in 2001?
Provide a succinct answer. 2.3. What is the ratio of the Aid flow from UN agencies (US$) in Malawi in 1999 to that in 2001?
Offer a terse response. 0.12. What is the ratio of the Aid flow from UN agencies (US$) of Latin America(developing only) in 1999 to that in 2002?
Give a very brief answer. 2.53. What is the ratio of the Aid flow from UN agencies (US$) of Middle East & North Africa (developing only) in 1999 to that in 2002?
Offer a terse response. 1.02. What is the ratio of the Aid flow from UN agencies (US$) of Gambia, The in 1999 to that in 2002?
Your answer should be compact. 1.48. What is the ratio of the Aid flow from UN agencies (US$) of Malawi in 1999 to that in 2002?
Your answer should be compact. 0.08. What is the ratio of the Aid flow from UN agencies (US$) of Latin America(developing only) in 2000 to that in 2001?
Offer a very short reply. 1.27. What is the ratio of the Aid flow from UN agencies (US$) in Middle East & North Africa (developing only) in 2000 to that in 2001?
Provide a succinct answer. 1.28. What is the ratio of the Aid flow from UN agencies (US$) of Gambia, The in 2000 to that in 2001?
Keep it short and to the point. 2.79. What is the ratio of the Aid flow from UN agencies (US$) in Malawi in 2000 to that in 2001?
Ensure brevity in your answer.  0.4. What is the ratio of the Aid flow from UN agencies (US$) in Latin America(developing only) in 2000 to that in 2002?
Your answer should be very brief. 1.87. What is the ratio of the Aid flow from UN agencies (US$) of Middle East & North Africa (developing only) in 2000 to that in 2002?
Make the answer very short. 1.12. What is the ratio of the Aid flow from UN agencies (US$) of Gambia, The in 2000 to that in 2002?
Your answer should be very brief. 1.79. What is the ratio of the Aid flow from UN agencies (US$) of Malawi in 2000 to that in 2002?
Your answer should be very brief. 0.25. What is the ratio of the Aid flow from UN agencies (US$) of Latin America(developing only) in 2001 to that in 2002?
Offer a very short reply. 1.47. What is the ratio of the Aid flow from UN agencies (US$) of Middle East & North Africa (developing only) in 2001 to that in 2002?
Your answer should be compact. 0.88. What is the ratio of the Aid flow from UN agencies (US$) of Gambia, The in 2001 to that in 2002?
Provide a succinct answer. 0.64. What is the ratio of the Aid flow from UN agencies (US$) of Malawi in 2001 to that in 2002?
Keep it short and to the point. 0.63. What is the difference between the highest and the second highest Aid flow from UN agencies (US$) in Latin America(developing only)?
Offer a terse response. 2.18e+06. What is the difference between the highest and the second highest Aid flow from UN agencies (US$) in Middle East & North Africa (developing only)?
Your answer should be compact. 1.09e+07. What is the difference between the highest and the second highest Aid flow from UN agencies (US$) of Gambia, The?
Provide a short and direct response. 1.02e+06. What is the difference between the highest and the second highest Aid flow from UN agencies (US$) in Malawi?
Your answer should be compact. 2.58e+06. What is the difference between the highest and the lowest Aid flow from UN agencies (US$) of Latin America(developing only)?
Provide a short and direct response. 3.05e+07. What is the difference between the highest and the lowest Aid flow from UN agencies (US$) of Middle East & North Africa (developing only)?
Ensure brevity in your answer.  1.72e+07. What is the difference between the highest and the lowest Aid flow from UN agencies (US$) of Gambia, The?
Offer a terse response. 2.03e+06. What is the difference between the highest and the lowest Aid flow from UN agencies (US$) in Malawi?
Your answer should be very brief. 6.47e+06. 